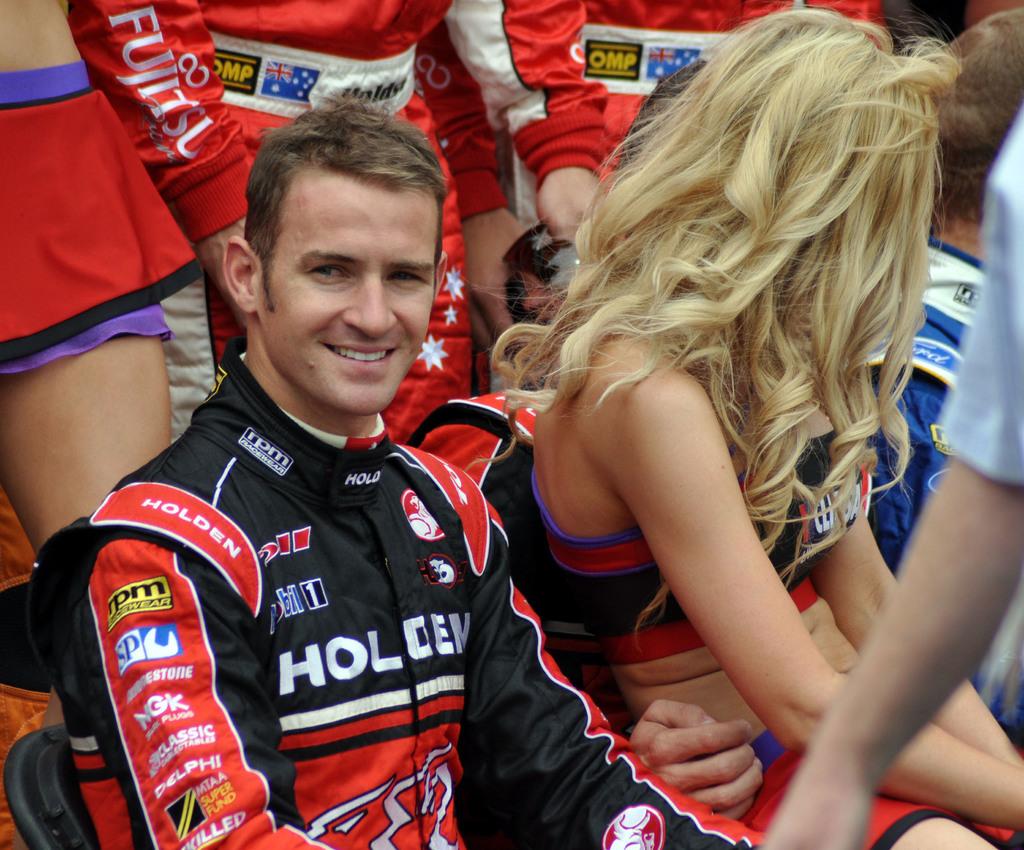What are the letters on the black in yellow patch on his sleeve?
Provide a short and direct response. Rpm. 